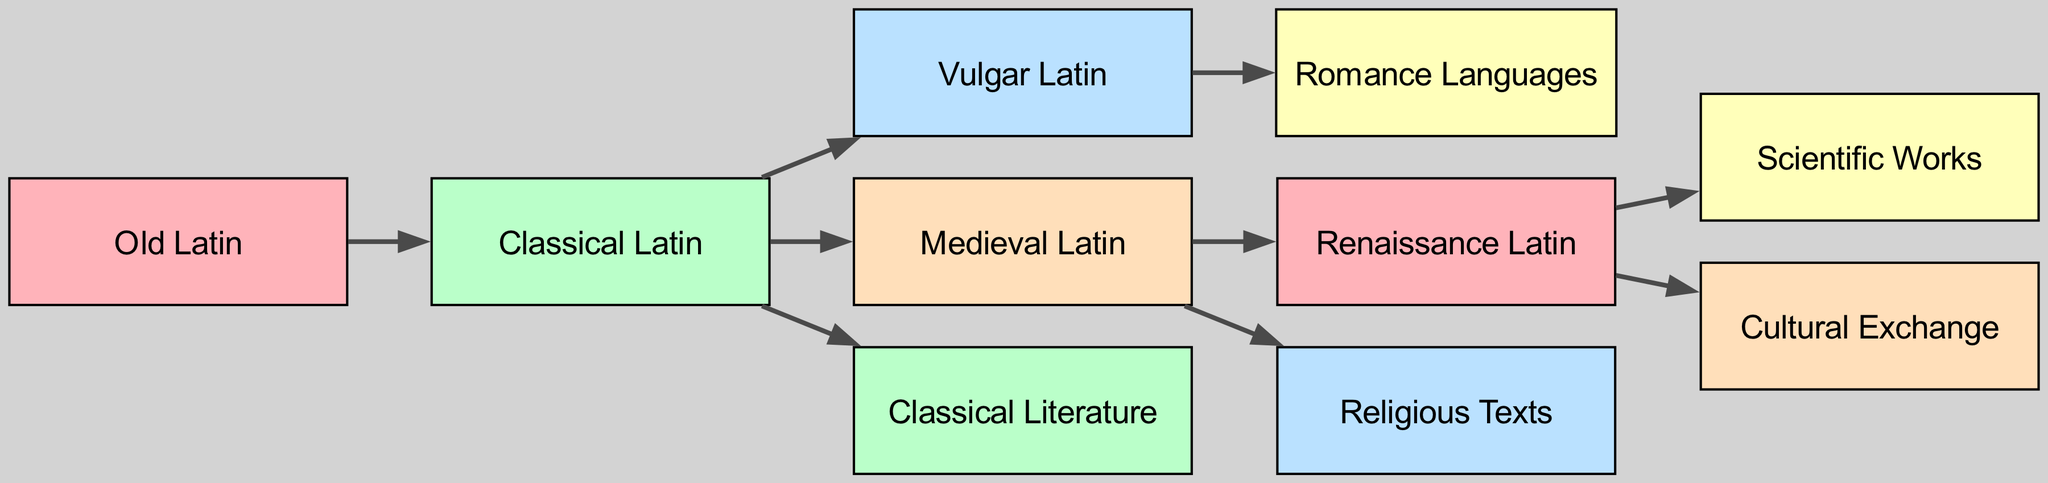What is the first stage in the evolution of Latin languages? The diagram shows Old Latin as the initial node, indicating it as the starting point for the evolution of Latin languages.
Answer: Old Latin How many nodes are present in the diagram? By counting the unique nodes listed in the diagram, it's clear there are 10 distinct nodes representing various stages and influences of Latin.
Answer: 10 What type of Latin evolves directly from Classical Latin? The link from Classical Latin to Vulgar Latin indicates this specific linguistic transformation, showing the evolution flow clearly.
Answer: Vulgar Latin Which languages emerge from Vulgar Latin? The diagram illustrates a clear pathway from Vulgar Latin to Romance Languages, designating them as the direct descendants in the evolution of Latin.
Answer: Romance Languages From which type of Latin do Renaissance Latin texts primarily derive? The directed link from Medieval Latin to Renaissance Latin signifies that Renaissance Latin primarily evolves from Medieval Latin.
Answer: Medieval Latin What type of works does Renaissance Latin produce? According to the diagram, two direct outputs from Renaissance Latin are Scientific Works and Cultural Exchange, clarifying the types of content produced during this period.
Answer: Scientific Works, Cultural Exchange Which types of texts develop from Medieval Latin? The diagram shows that Medieval Latin leads to Religious Texts, indicating its relevance in ecclesiastical literature.
Answer: Religious Texts What is a key influence on the transition from Classical Latin to Renaissance Latin? Following the flow, it's evident that Medieval Latin acts as a crucial intermediary stage before evolving into Renaissance Latin.
Answer: Medieval Latin How many links are there in the diagram? By analyzing the connections (links) shown, a total of 8 unique transitions between different types of Latin and influences can be identified.
Answer: 8 Which era serves as the last stage in the transition of Latin languages? The final node in the flow of the diagram indicates that Renaissance Latin is the concluding stage in the evolution of Latin languages.
Answer: Renaissance Latin 